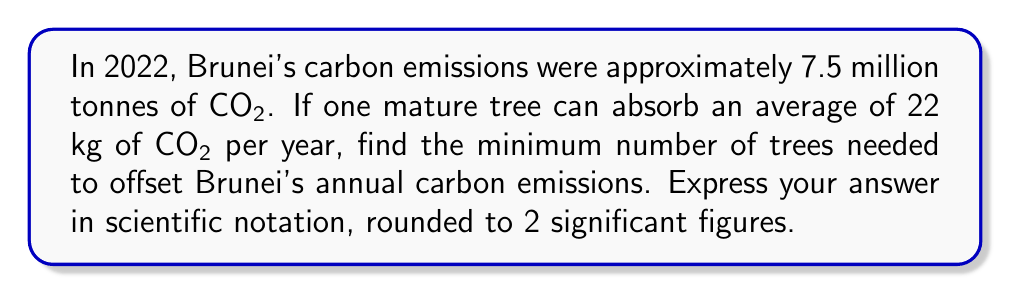Can you answer this question? Let's approach this step-by-step:

1) First, we need to convert Brunei's carbon emissions from tonnes to kilograms:
   $7.5 \text{ million tonnes} = 7.5 \times 10^6 \text{ tonnes}$
   $7.5 \times 10^6 \text{ tonnes} = 7.5 \times 10^6 \times 1000 \text{ kg} = 7.5 \times 10^9 \text{ kg}$

2) Now, we set up an inequality to find the minimum number of trees (let's call it $x$):
   $22x \geq 7.5 \times 10^9$

3) Solve for $x$:
   $x \geq \frac{7.5 \times 10^9}{22}$

4) Calculate:
   $x \geq 340,909,090.9090909...$

5) Since we need a whole number of trees and we're looking for the minimum, we round up:
   $x = 340,909,091$

6) Express in scientific notation with 2 significant figures:
   $x = 3.4 \times 10^8$

Therefore, the minimum number of trees needed is $3.4 \times 10^8$.
Answer: $3.4 \times 10^8$ trees 